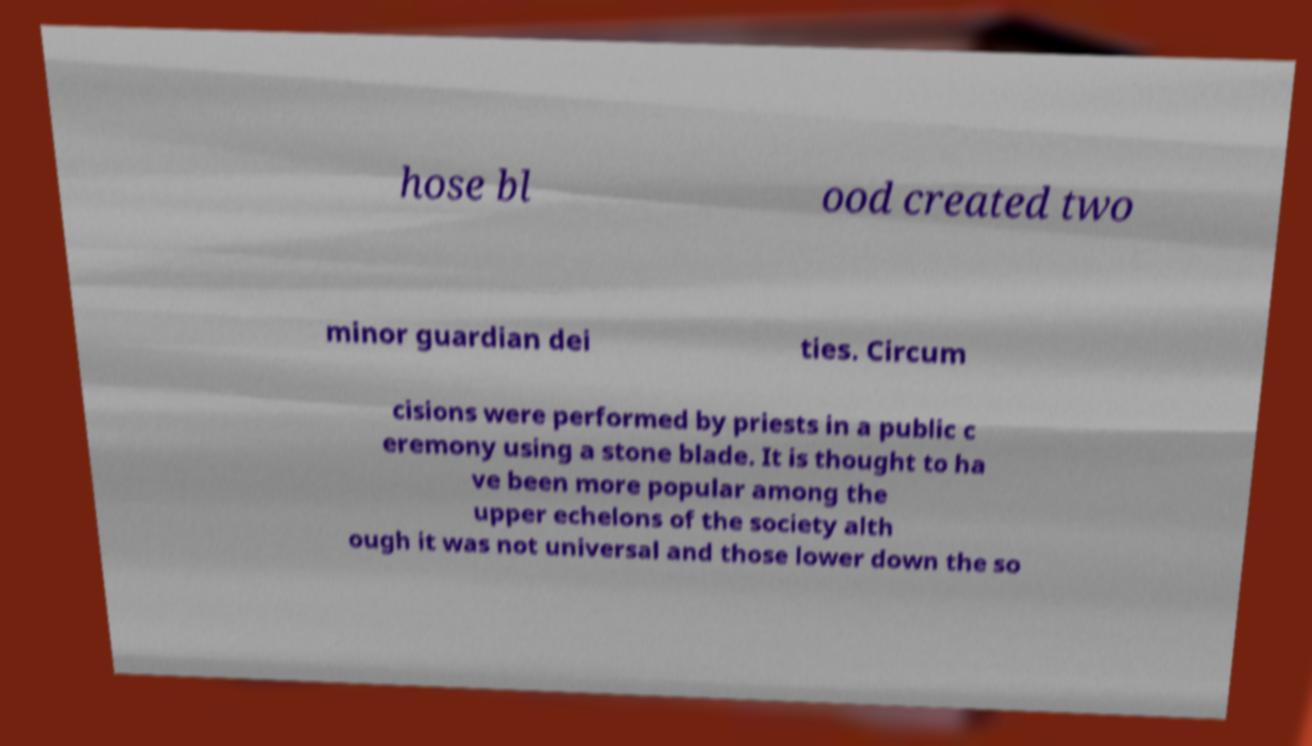Could you assist in decoding the text presented in this image and type it out clearly? hose bl ood created two minor guardian dei ties. Circum cisions were performed by priests in a public c eremony using a stone blade. It is thought to ha ve been more popular among the upper echelons of the society alth ough it was not universal and those lower down the so 